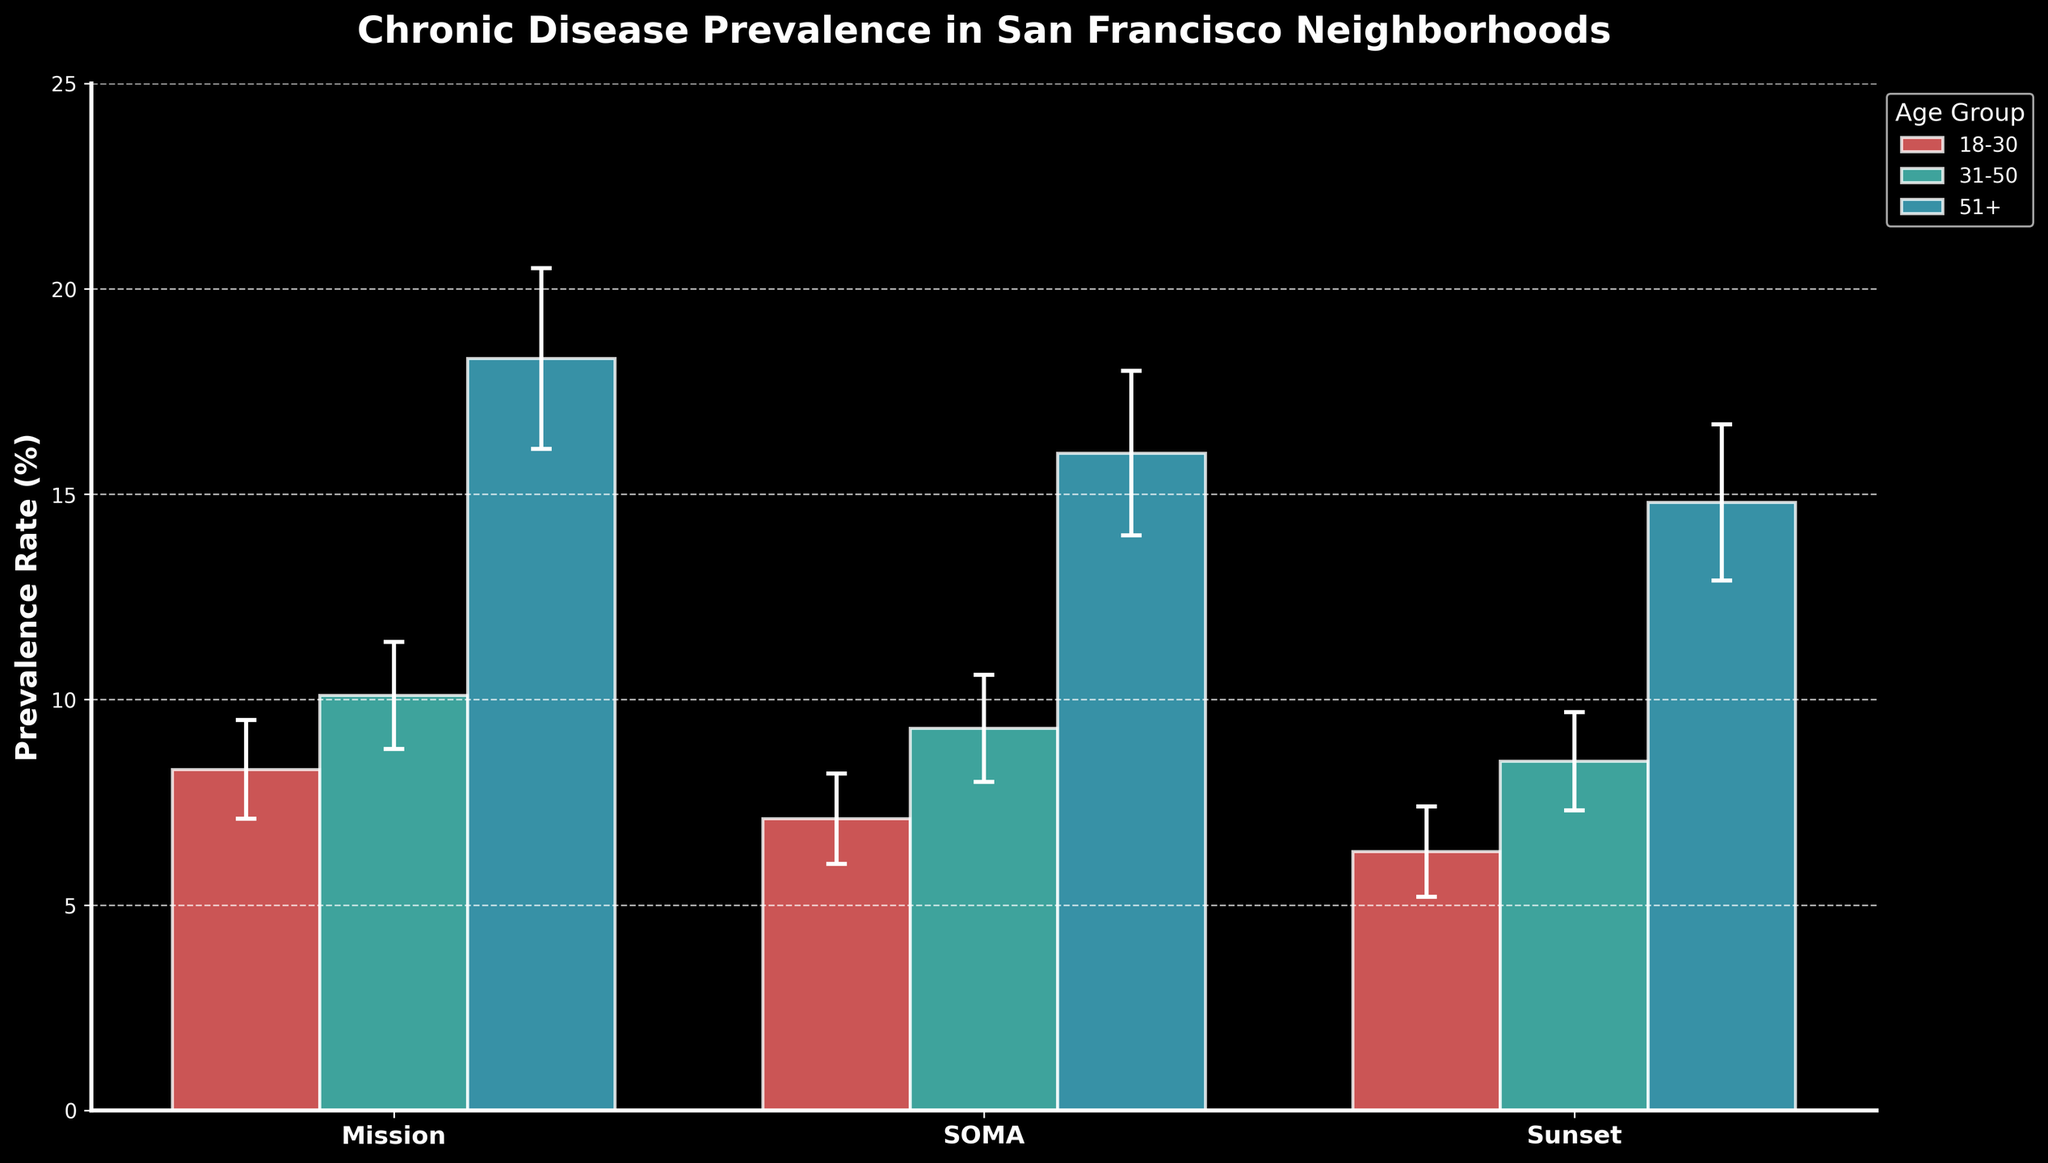What is the title of the figure? The title of the figure is displayed at the top in bold text.
Answer: Chronic Disease Prevalence in San Francisco Neighborhoods What is the prevalence rate of chronic diseases for the 31-50 age group in the Mission neighborhood? The bar labeled "31-50" in the Mission neighborhood has a height representing the prevalence rate.
Answer: 10.1% Which neighborhood has the highest prevalence of chronic diseases in the 51+ age group? By comparing the heights of the bars labeled "51+" across all neighborhoods, the tallest bar indicates the highest prevalence.
Answer: Mission What is the color used for the 18-30 age group? Each age group is color-coded, and the bar color for the 18-30 age group can be observed.
Answer: Red How does the prevalence of chronic diseases in the 31-50 age group in the Sunset neighborhood compare to the same age group in the SOMA neighborhood? Compare the heights of the bars labeled "31-50" for both the Sunset and SOMA neighborhoods.
Answer: Sunset is higher What is the error margin for the 18-30 age group in the Sunset neighborhood? The error margin is depicted by the error bars extending above and below the bars.
Answer: ±1.1% What is the average prevalence rate of chronic diseases for the 51+ age group across all neighborhoods? Calculate the average of the prevalence rates for the 51+ age group in all three neighborhoods. (Mission: 18.3%, SOMA: 16.0%, Sunset: 14.8%)
Answer: (18.3 + 16 + 14.8) / 3 = 16.37% Which age group has the smallest error margin across all neighborhoods? Compare the error bars for each age group across all neighborhoods. The smallest error bar indicates the smallest error margin.
Answer: 18-30 What are the axes labels in the figure? The labels on the x-axis and y-axis describe what is being represented.
Answer: Neighborhoods (x-axis), Prevalence Rate (%) (y-axis) What is the difference in prevalence rates between the 31-50 and 51+ age groups in the Mission neighborhood? Subtract the prevalence rate of the 31-50 age group from that of the 51+ age group in the Mission neighborhood.
Answer: 18.3 - 10.1 = 8.2% 